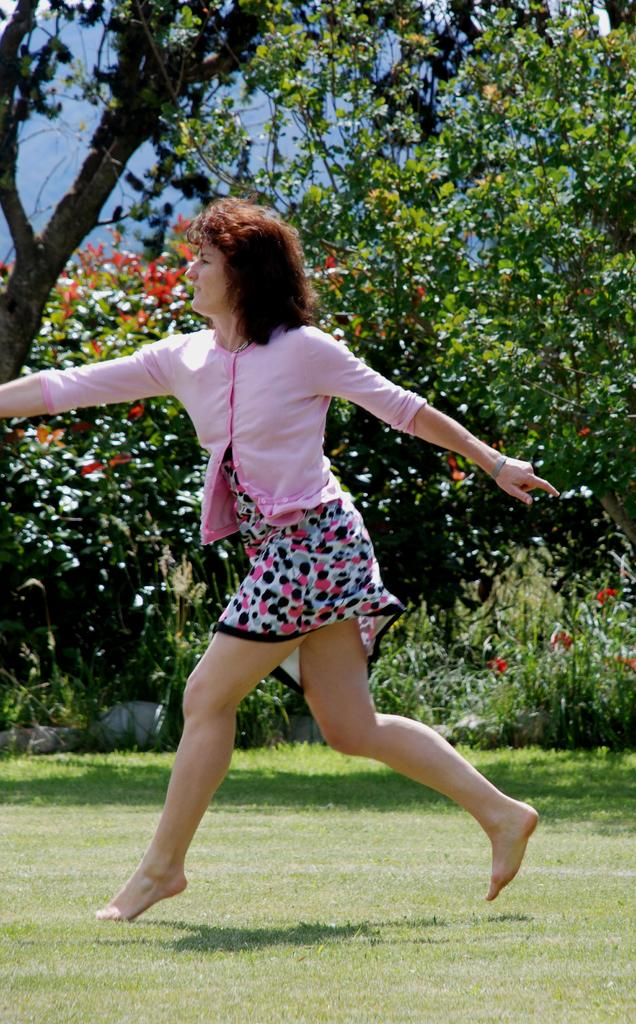Who is the main subject in the image? There is a woman in the center of the image. What type of natural elements can be seen in the image? There are trees, plants, grass, and the sky visible in the image. What type of produce is the squirrel holding in the image? There is no squirrel present in the image, and therefore no produce can be observed. Is there a club visible in the image? There is no club present in the image. 